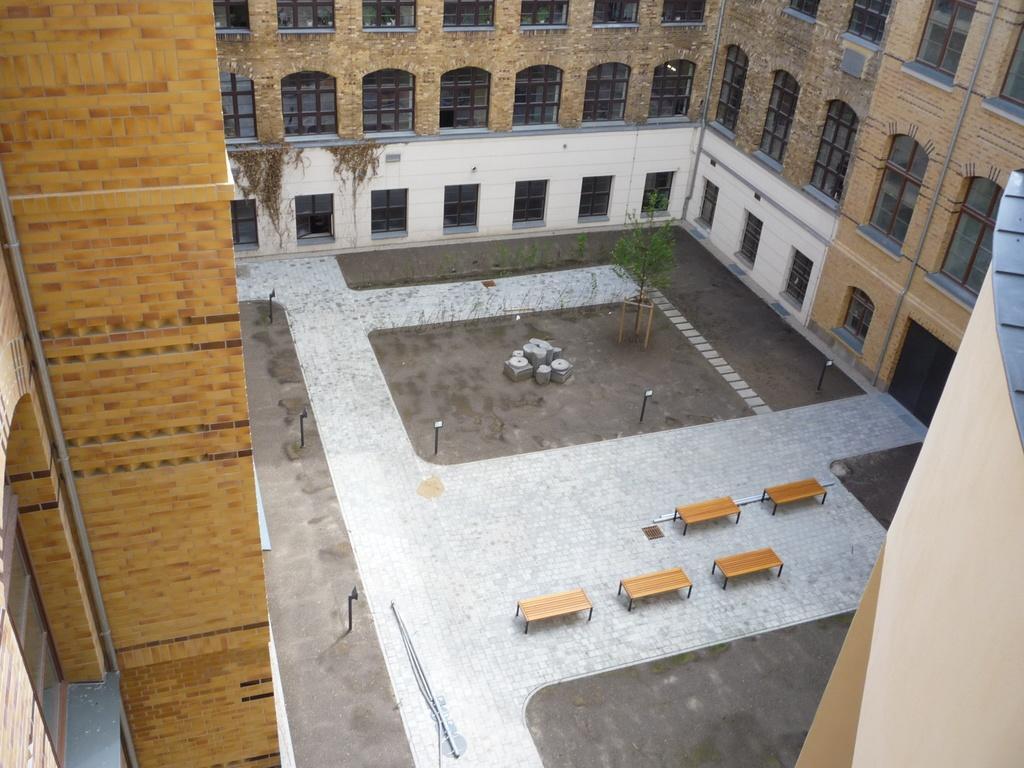Could you give a brief overview of what you see in this image? In this image I can see a building along with the windows. In the middle of the image there is ground and there are few benches and a plant placed on the ground. 